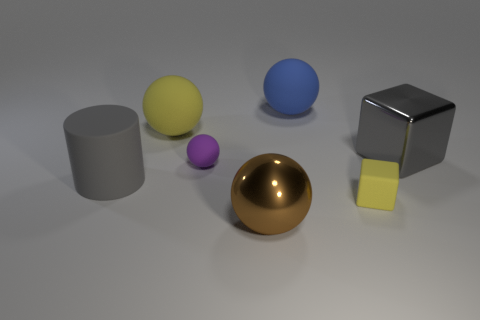Add 1 gray objects. How many objects exist? 8 Subtract all blocks. How many objects are left? 5 Add 4 large matte cylinders. How many large matte cylinders exist? 5 Subtract 0 cyan spheres. How many objects are left? 7 Subtract all big gray shiny things. Subtract all purple things. How many objects are left? 5 Add 4 rubber cylinders. How many rubber cylinders are left? 5 